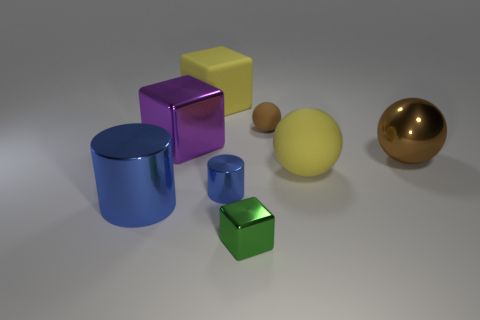How many large matte things are to the right of the big rubber thing that is behind the big brown metal ball?
Your response must be concise. 1. How many things are both in front of the large yellow matte cube and behind the green thing?
Ensure brevity in your answer.  6. How many other objects are the same material as the large brown thing?
Give a very brief answer. 4. There is a metal block that is to the right of the blue object that is to the right of the large blue shiny cylinder; what color is it?
Give a very brief answer. Green. Does the cylinder that is to the right of the purple thing have the same color as the large metallic cylinder?
Offer a very short reply. Yes. Do the brown rubber sphere and the green object have the same size?
Provide a succinct answer. Yes. What shape is the blue metallic thing that is the same size as the yellow rubber cube?
Your response must be concise. Cylinder. Is the size of the brown matte object that is behind the green thing the same as the purple block?
Provide a short and direct response. No. There is a yellow object that is the same size as the matte block; what material is it?
Keep it short and to the point. Rubber. Is there a thing that is in front of the yellow rubber object to the right of the big matte object behind the shiny sphere?
Your response must be concise. Yes. 